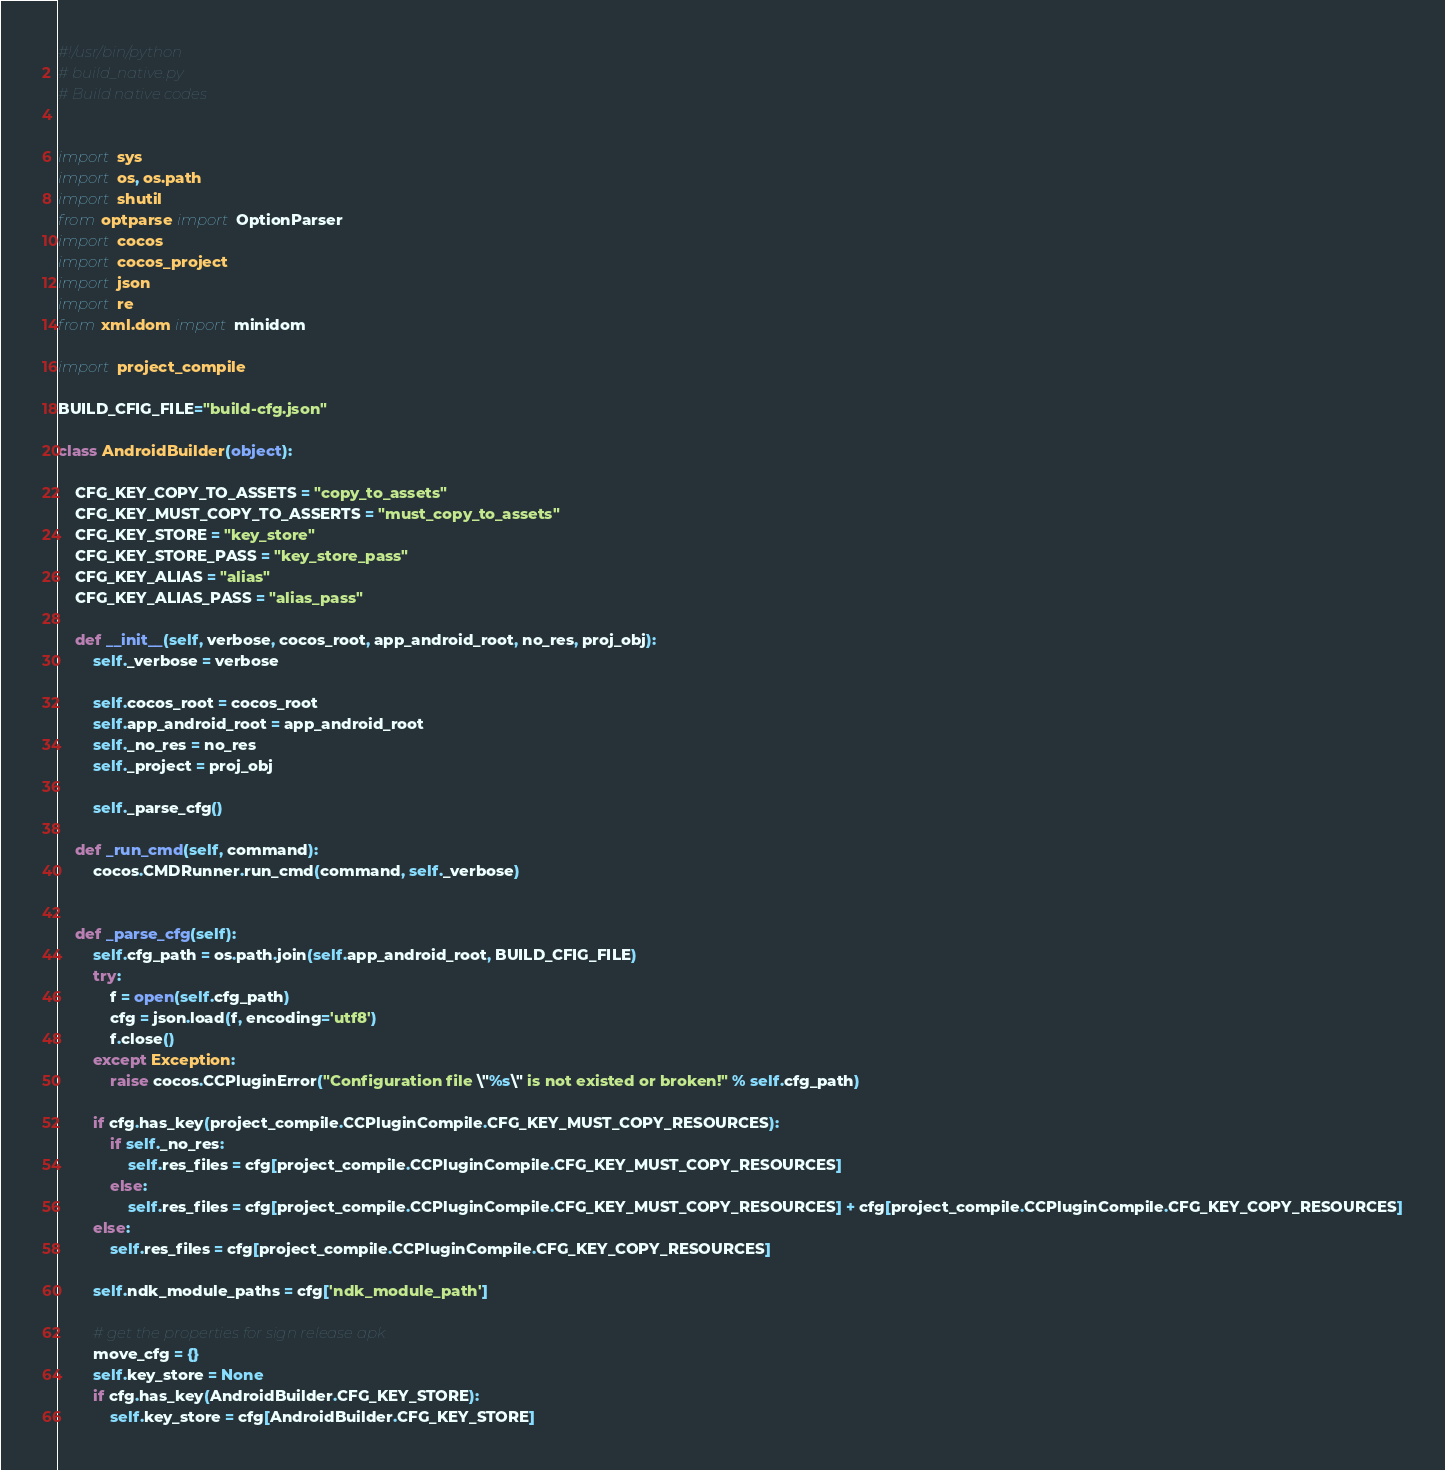<code> <loc_0><loc_0><loc_500><loc_500><_Python_>#!/usr/bin/python
# build_native.py
# Build native codes


import sys
import os, os.path
import shutil
from optparse import OptionParser
import cocos
import cocos_project
import json
import re
from xml.dom import minidom

import project_compile

BUILD_CFIG_FILE="build-cfg.json"

class AndroidBuilder(object):

    CFG_KEY_COPY_TO_ASSETS = "copy_to_assets"
    CFG_KEY_MUST_COPY_TO_ASSERTS = "must_copy_to_assets"
    CFG_KEY_STORE = "key_store"
    CFG_KEY_STORE_PASS = "key_store_pass"
    CFG_KEY_ALIAS = "alias"
    CFG_KEY_ALIAS_PASS = "alias_pass"

    def __init__(self, verbose, cocos_root, app_android_root, no_res, proj_obj):
        self._verbose = verbose

        self.cocos_root = cocos_root
        self.app_android_root = app_android_root
        self._no_res = no_res
        self._project = proj_obj

        self._parse_cfg()

    def _run_cmd(self, command):
        cocos.CMDRunner.run_cmd(command, self._verbose)


    def _parse_cfg(self):
        self.cfg_path = os.path.join(self.app_android_root, BUILD_CFIG_FILE)
        try:
            f = open(self.cfg_path)
            cfg = json.load(f, encoding='utf8')
            f.close()
        except Exception:
            raise cocos.CCPluginError("Configuration file \"%s\" is not existed or broken!" % self.cfg_path)

        if cfg.has_key(project_compile.CCPluginCompile.CFG_KEY_MUST_COPY_RESOURCES):
            if self._no_res:
                self.res_files = cfg[project_compile.CCPluginCompile.CFG_KEY_MUST_COPY_RESOURCES]
            else:
                self.res_files = cfg[project_compile.CCPluginCompile.CFG_KEY_MUST_COPY_RESOURCES] + cfg[project_compile.CCPluginCompile.CFG_KEY_COPY_RESOURCES]
        else:
            self.res_files = cfg[project_compile.CCPluginCompile.CFG_KEY_COPY_RESOURCES]

        self.ndk_module_paths = cfg['ndk_module_path']

        # get the properties for sign release apk
        move_cfg = {}
        self.key_store = None
        if cfg.has_key(AndroidBuilder.CFG_KEY_STORE):
            self.key_store = cfg[AndroidBuilder.CFG_KEY_STORE]</code> 